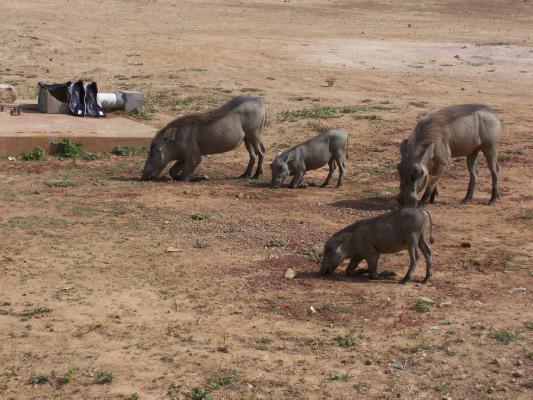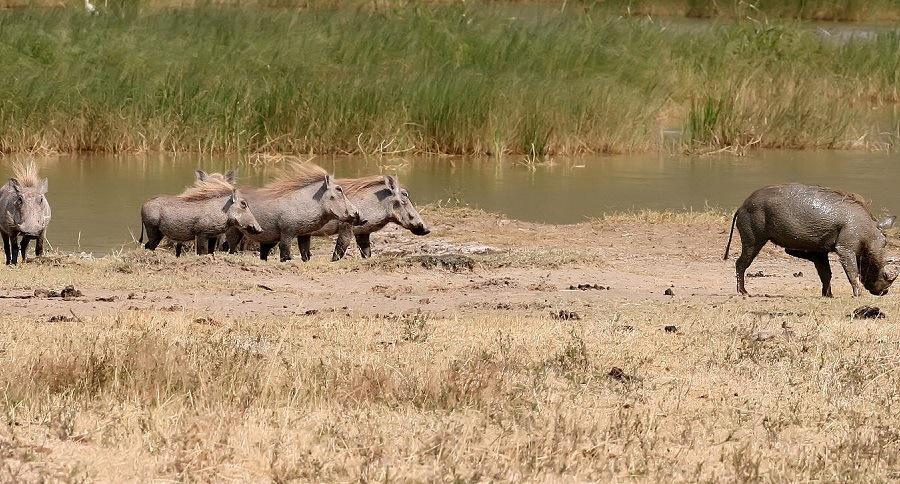The first image is the image on the left, the second image is the image on the right. Considering the images on both sides, is "The warthogs in one image are next to a body of water." valid? Answer yes or no. Yes. The first image is the image on the left, the second image is the image on the right. Assess this claim about the two images: "Warthogs are standing in front of a body of nearby visible water, in one image.". Correct or not? Answer yes or no. Yes. 